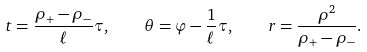<formula> <loc_0><loc_0><loc_500><loc_500>t = \frac { \rho _ { + } - \rho _ { - } } { \ell } \tau , \quad \theta = \varphi - \frac { 1 } { \ell } \tau , \quad r = \frac { \rho ^ { 2 } } { \rho _ { + } - \rho _ { - } } .</formula> 